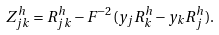Convert formula to latex. <formula><loc_0><loc_0><loc_500><loc_500>Z ^ { h } _ { j k } = R ^ { h } _ { j k } - F ^ { - 2 } ( y _ { j } R ^ { h } _ { k } - y _ { k } R ^ { h } _ { j } ) .</formula> 